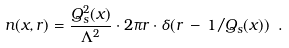<formula> <loc_0><loc_0><loc_500><loc_500>n ( x , r ) = \frac { Q _ { s } ^ { 2 } ( x ) } { \Lambda ^ { 2 } } \cdot 2 \pi r \cdot \delta ( r \, - \, 1 / Q _ { s } ( x ) ) \ .</formula> 